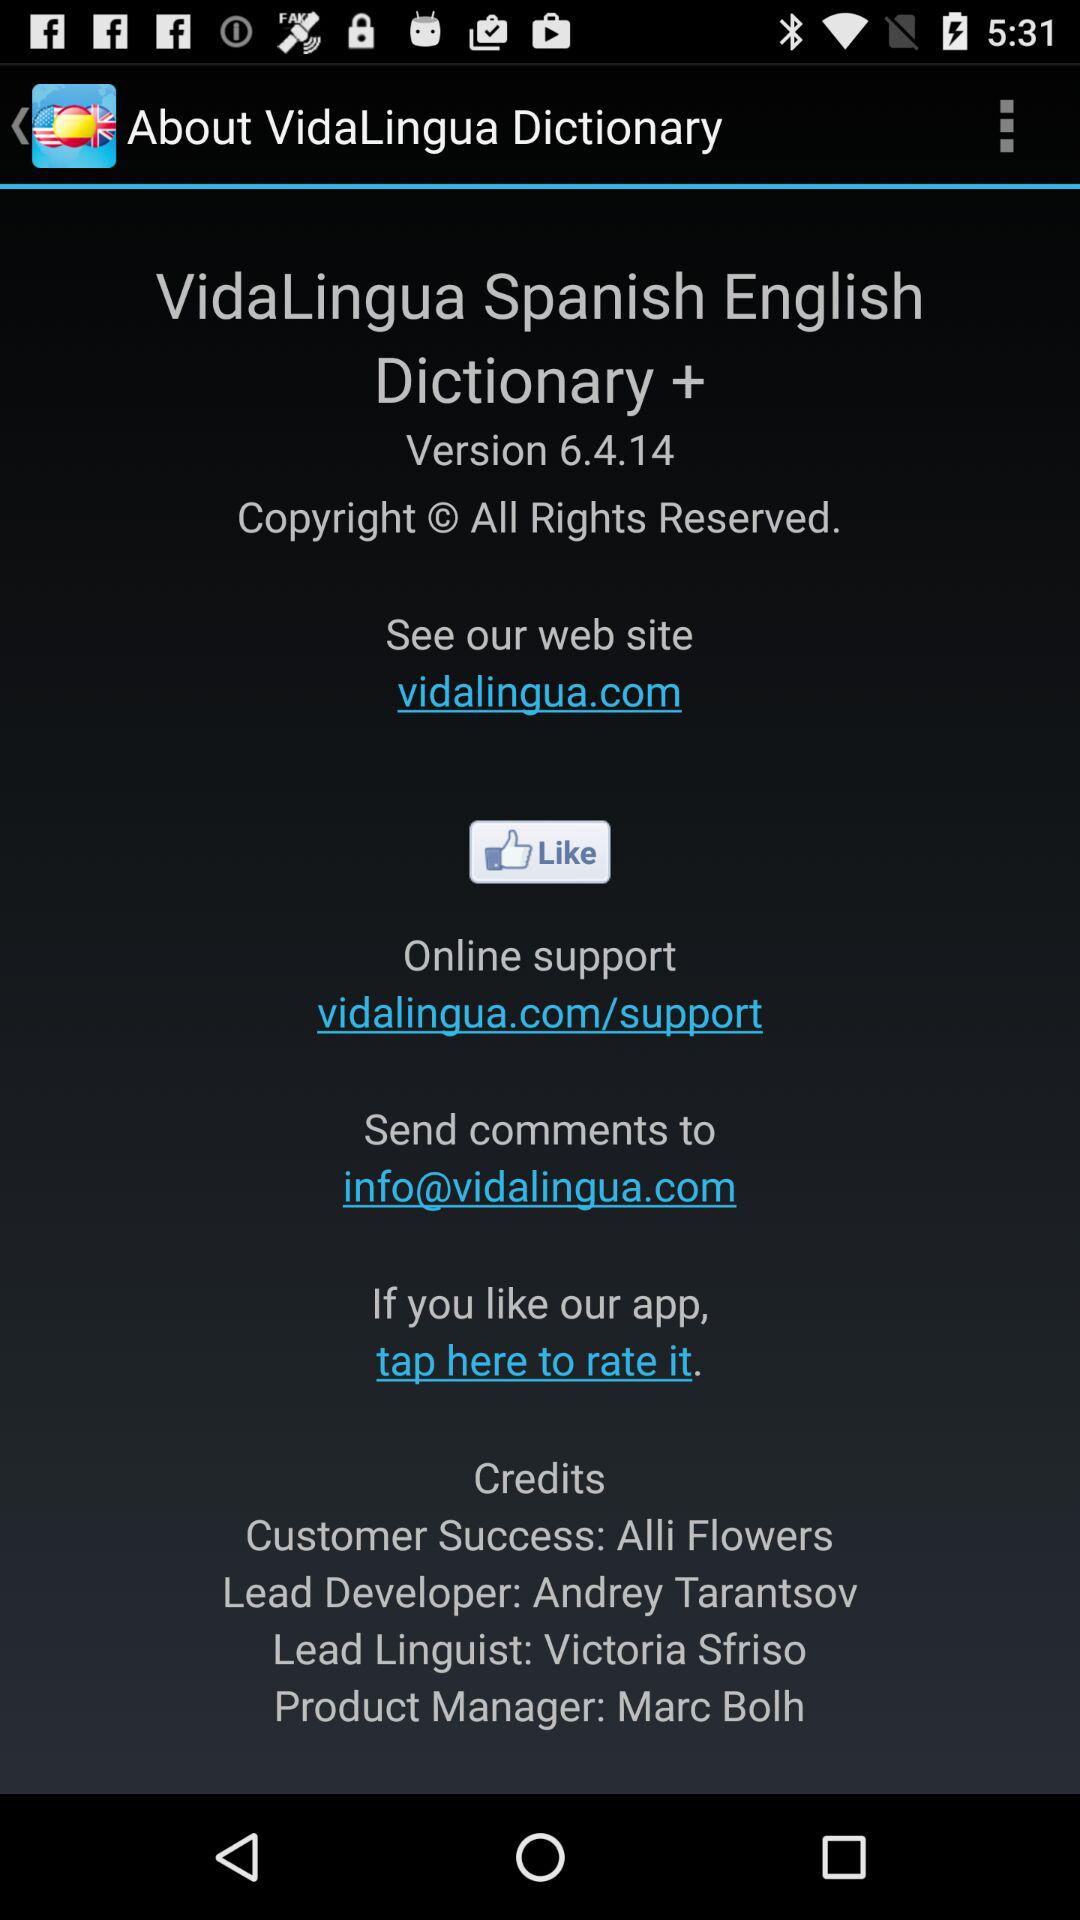Who is the linguist lead? The linguist lead is Victoria Sfriso. 